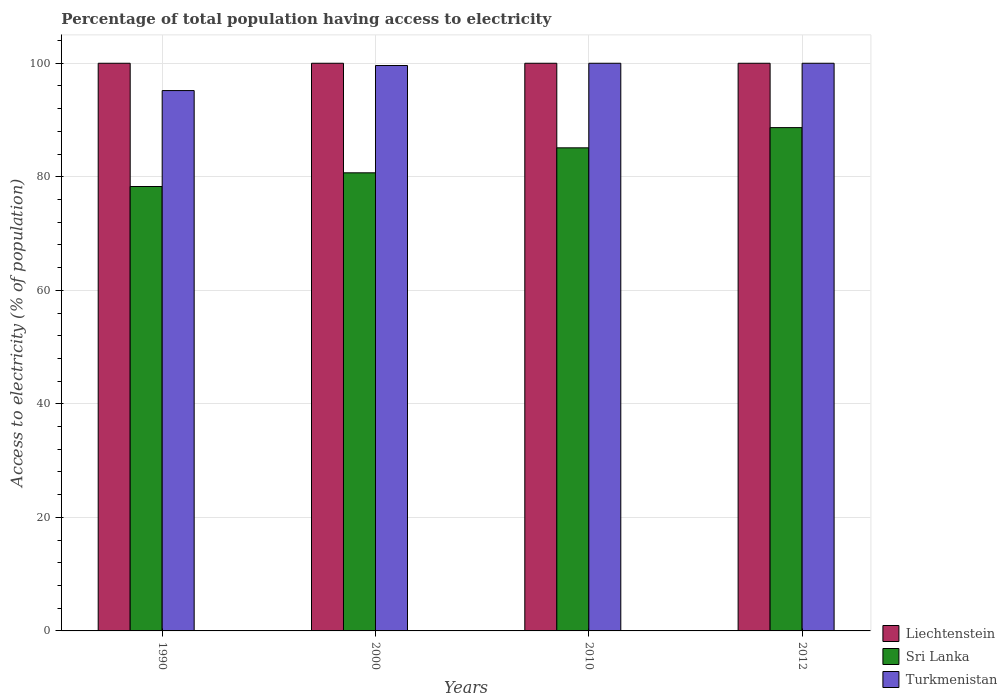How many different coloured bars are there?
Offer a very short reply. 3. Are the number of bars on each tick of the X-axis equal?
Your answer should be very brief. Yes. How many bars are there on the 3rd tick from the left?
Provide a succinct answer. 3. In how many cases, is the number of bars for a given year not equal to the number of legend labels?
Offer a terse response. 0. What is the percentage of population that have access to electricity in Turkmenistan in 2000?
Ensure brevity in your answer.  99.6. Across all years, what is the maximum percentage of population that have access to electricity in Turkmenistan?
Give a very brief answer. 100. Across all years, what is the minimum percentage of population that have access to electricity in Sri Lanka?
Offer a very short reply. 78.29. In which year was the percentage of population that have access to electricity in Turkmenistan maximum?
Your answer should be compact. 2010. In which year was the percentage of population that have access to electricity in Liechtenstein minimum?
Keep it short and to the point. 1990. What is the total percentage of population that have access to electricity in Turkmenistan in the graph?
Give a very brief answer. 394.79. What is the difference between the percentage of population that have access to electricity in Turkmenistan in 1990 and that in 2000?
Provide a short and direct response. -4.41. What is the difference between the percentage of population that have access to electricity in Sri Lanka in 2000 and the percentage of population that have access to electricity in Turkmenistan in 2012?
Provide a short and direct response. -19.3. In the year 2010, what is the difference between the percentage of population that have access to electricity in Sri Lanka and percentage of population that have access to electricity in Liechtenstein?
Offer a terse response. -14.9. What is the ratio of the percentage of population that have access to electricity in Sri Lanka in 2000 to that in 2012?
Your response must be concise. 0.91. Is the percentage of population that have access to electricity in Turkmenistan in 2000 less than that in 2012?
Offer a terse response. Yes. Is the difference between the percentage of population that have access to electricity in Sri Lanka in 1990 and 2012 greater than the difference between the percentage of population that have access to electricity in Liechtenstein in 1990 and 2012?
Offer a terse response. No. What is the difference between the highest and the second highest percentage of population that have access to electricity in Sri Lanka?
Provide a short and direct response. 3.56. What is the difference between the highest and the lowest percentage of population that have access to electricity in Sri Lanka?
Provide a short and direct response. 10.37. What does the 1st bar from the left in 2010 represents?
Provide a succinct answer. Liechtenstein. What does the 1st bar from the right in 2010 represents?
Your answer should be compact. Turkmenistan. Is it the case that in every year, the sum of the percentage of population that have access to electricity in Liechtenstein and percentage of population that have access to electricity in Turkmenistan is greater than the percentage of population that have access to electricity in Sri Lanka?
Offer a very short reply. Yes. How many bars are there?
Provide a short and direct response. 12. Are all the bars in the graph horizontal?
Your response must be concise. No. How many years are there in the graph?
Provide a succinct answer. 4. What is the difference between two consecutive major ticks on the Y-axis?
Keep it short and to the point. 20. Where does the legend appear in the graph?
Offer a very short reply. Bottom right. How many legend labels are there?
Your response must be concise. 3. What is the title of the graph?
Offer a very short reply. Percentage of total population having access to electricity. What is the label or title of the Y-axis?
Offer a very short reply. Access to electricity (% of population). What is the Access to electricity (% of population) in Liechtenstein in 1990?
Ensure brevity in your answer.  100. What is the Access to electricity (% of population) of Sri Lanka in 1990?
Provide a succinct answer. 78.29. What is the Access to electricity (% of population) in Turkmenistan in 1990?
Provide a succinct answer. 95.19. What is the Access to electricity (% of population) in Sri Lanka in 2000?
Make the answer very short. 80.7. What is the Access to electricity (% of population) of Turkmenistan in 2000?
Give a very brief answer. 99.6. What is the Access to electricity (% of population) of Sri Lanka in 2010?
Give a very brief answer. 85.1. What is the Access to electricity (% of population) of Sri Lanka in 2012?
Offer a terse response. 88.66. Across all years, what is the maximum Access to electricity (% of population) in Liechtenstein?
Offer a terse response. 100. Across all years, what is the maximum Access to electricity (% of population) in Sri Lanka?
Your response must be concise. 88.66. Across all years, what is the minimum Access to electricity (% of population) of Liechtenstein?
Offer a very short reply. 100. Across all years, what is the minimum Access to electricity (% of population) in Sri Lanka?
Your answer should be compact. 78.29. Across all years, what is the minimum Access to electricity (% of population) of Turkmenistan?
Give a very brief answer. 95.19. What is the total Access to electricity (% of population) of Liechtenstein in the graph?
Offer a very short reply. 400. What is the total Access to electricity (% of population) in Sri Lanka in the graph?
Your answer should be very brief. 332.75. What is the total Access to electricity (% of population) of Turkmenistan in the graph?
Your answer should be very brief. 394.79. What is the difference between the Access to electricity (% of population) of Sri Lanka in 1990 and that in 2000?
Provide a short and direct response. -2.41. What is the difference between the Access to electricity (% of population) of Turkmenistan in 1990 and that in 2000?
Your answer should be very brief. -4.41. What is the difference between the Access to electricity (% of population) in Liechtenstein in 1990 and that in 2010?
Offer a terse response. 0. What is the difference between the Access to electricity (% of population) in Sri Lanka in 1990 and that in 2010?
Offer a terse response. -6.81. What is the difference between the Access to electricity (% of population) of Turkmenistan in 1990 and that in 2010?
Your response must be concise. -4.81. What is the difference between the Access to electricity (% of population) in Sri Lanka in 1990 and that in 2012?
Your answer should be compact. -10.37. What is the difference between the Access to electricity (% of population) in Turkmenistan in 1990 and that in 2012?
Offer a terse response. -4.81. What is the difference between the Access to electricity (% of population) of Sri Lanka in 2000 and that in 2010?
Make the answer very short. -4.4. What is the difference between the Access to electricity (% of population) in Sri Lanka in 2000 and that in 2012?
Provide a short and direct response. -7.96. What is the difference between the Access to electricity (% of population) of Turkmenistan in 2000 and that in 2012?
Your response must be concise. -0.4. What is the difference between the Access to electricity (% of population) of Liechtenstein in 2010 and that in 2012?
Ensure brevity in your answer.  0. What is the difference between the Access to electricity (% of population) of Sri Lanka in 2010 and that in 2012?
Ensure brevity in your answer.  -3.56. What is the difference between the Access to electricity (% of population) of Liechtenstein in 1990 and the Access to electricity (% of population) of Sri Lanka in 2000?
Offer a terse response. 19.3. What is the difference between the Access to electricity (% of population) in Liechtenstein in 1990 and the Access to electricity (% of population) in Turkmenistan in 2000?
Your answer should be very brief. 0.4. What is the difference between the Access to electricity (% of population) of Sri Lanka in 1990 and the Access to electricity (% of population) of Turkmenistan in 2000?
Offer a terse response. -21.31. What is the difference between the Access to electricity (% of population) in Liechtenstein in 1990 and the Access to electricity (% of population) in Sri Lanka in 2010?
Give a very brief answer. 14.9. What is the difference between the Access to electricity (% of population) in Liechtenstein in 1990 and the Access to electricity (% of population) in Turkmenistan in 2010?
Your answer should be compact. 0. What is the difference between the Access to electricity (% of population) in Sri Lanka in 1990 and the Access to electricity (% of population) in Turkmenistan in 2010?
Your answer should be very brief. -21.71. What is the difference between the Access to electricity (% of population) in Liechtenstein in 1990 and the Access to electricity (% of population) in Sri Lanka in 2012?
Provide a short and direct response. 11.34. What is the difference between the Access to electricity (% of population) in Sri Lanka in 1990 and the Access to electricity (% of population) in Turkmenistan in 2012?
Give a very brief answer. -21.71. What is the difference between the Access to electricity (% of population) in Liechtenstein in 2000 and the Access to electricity (% of population) in Sri Lanka in 2010?
Keep it short and to the point. 14.9. What is the difference between the Access to electricity (% of population) of Sri Lanka in 2000 and the Access to electricity (% of population) of Turkmenistan in 2010?
Ensure brevity in your answer.  -19.3. What is the difference between the Access to electricity (% of population) in Liechtenstein in 2000 and the Access to electricity (% of population) in Sri Lanka in 2012?
Offer a terse response. 11.34. What is the difference between the Access to electricity (% of population) of Sri Lanka in 2000 and the Access to electricity (% of population) of Turkmenistan in 2012?
Provide a short and direct response. -19.3. What is the difference between the Access to electricity (% of population) of Liechtenstein in 2010 and the Access to electricity (% of population) of Sri Lanka in 2012?
Keep it short and to the point. 11.34. What is the difference between the Access to electricity (% of population) of Liechtenstein in 2010 and the Access to electricity (% of population) of Turkmenistan in 2012?
Your answer should be very brief. 0. What is the difference between the Access to electricity (% of population) of Sri Lanka in 2010 and the Access to electricity (% of population) of Turkmenistan in 2012?
Offer a very short reply. -14.9. What is the average Access to electricity (% of population) of Liechtenstein per year?
Your answer should be very brief. 100. What is the average Access to electricity (% of population) of Sri Lanka per year?
Provide a short and direct response. 83.19. What is the average Access to electricity (% of population) in Turkmenistan per year?
Your answer should be compact. 98.7. In the year 1990, what is the difference between the Access to electricity (% of population) in Liechtenstein and Access to electricity (% of population) in Sri Lanka?
Provide a short and direct response. 21.71. In the year 1990, what is the difference between the Access to electricity (% of population) in Liechtenstein and Access to electricity (% of population) in Turkmenistan?
Give a very brief answer. 4.81. In the year 1990, what is the difference between the Access to electricity (% of population) of Sri Lanka and Access to electricity (% of population) of Turkmenistan?
Your answer should be very brief. -16.9. In the year 2000, what is the difference between the Access to electricity (% of population) of Liechtenstein and Access to electricity (% of population) of Sri Lanka?
Make the answer very short. 19.3. In the year 2000, what is the difference between the Access to electricity (% of population) in Sri Lanka and Access to electricity (% of population) in Turkmenistan?
Provide a short and direct response. -18.9. In the year 2010, what is the difference between the Access to electricity (% of population) of Liechtenstein and Access to electricity (% of population) of Sri Lanka?
Ensure brevity in your answer.  14.9. In the year 2010, what is the difference between the Access to electricity (% of population) in Sri Lanka and Access to electricity (% of population) in Turkmenistan?
Keep it short and to the point. -14.9. In the year 2012, what is the difference between the Access to electricity (% of population) of Liechtenstein and Access to electricity (% of population) of Sri Lanka?
Give a very brief answer. 11.34. In the year 2012, what is the difference between the Access to electricity (% of population) in Liechtenstein and Access to electricity (% of population) in Turkmenistan?
Ensure brevity in your answer.  0. In the year 2012, what is the difference between the Access to electricity (% of population) in Sri Lanka and Access to electricity (% of population) in Turkmenistan?
Provide a short and direct response. -11.34. What is the ratio of the Access to electricity (% of population) in Liechtenstein in 1990 to that in 2000?
Keep it short and to the point. 1. What is the ratio of the Access to electricity (% of population) in Sri Lanka in 1990 to that in 2000?
Offer a very short reply. 0.97. What is the ratio of the Access to electricity (% of population) in Turkmenistan in 1990 to that in 2000?
Your response must be concise. 0.96. What is the ratio of the Access to electricity (% of population) in Sri Lanka in 1990 to that in 2010?
Ensure brevity in your answer.  0.92. What is the ratio of the Access to electricity (% of population) in Turkmenistan in 1990 to that in 2010?
Make the answer very short. 0.95. What is the ratio of the Access to electricity (% of population) of Sri Lanka in 1990 to that in 2012?
Your response must be concise. 0.88. What is the ratio of the Access to electricity (% of population) of Turkmenistan in 1990 to that in 2012?
Your answer should be compact. 0.95. What is the ratio of the Access to electricity (% of population) in Liechtenstein in 2000 to that in 2010?
Offer a terse response. 1. What is the ratio of the Access to electricity (% of population) in Sri Lanka in 2000 to that in 2010?
Ensure brevity in your answer.  0.95. What is the ratio of the Access to electricity (% of population) in Turkmenistan in 2000 to that in 2010?
Provide a short and direct response. 1. What is the ratio of the Access to electricity (% of population) of Liechtenstein in 2000 to that in 2012?
Offer a very short reply. 1. What is the ratio of the Access to electricity (% of population) of Sri Lanka in 2000 to that in 2012?
Provide a succinct answer. 0.91. What is the ratio of the Access to electricity (% of population) in Sri Lanka in 2010 to that in 2012?
Offer a terse response. 0.96. What is the difference between the highest and the second highest Access to electricity (% of population) of Sri Lanka?
Provide a short and direct response. 3.56. What is the difference between the highest and the lowest Access to electricity (% of population) in Liechtenstein?
Your answer should be very brief. 0. What is the difference between the highest and the lowest Access to electricity (% of population) in Sri Lanka?
Your answer should be very brief. 10.37. What is the difference between the highest and the lowest Access to electricity (% of population) in Turkmenistan?
Make the answer very short. 4.81. 